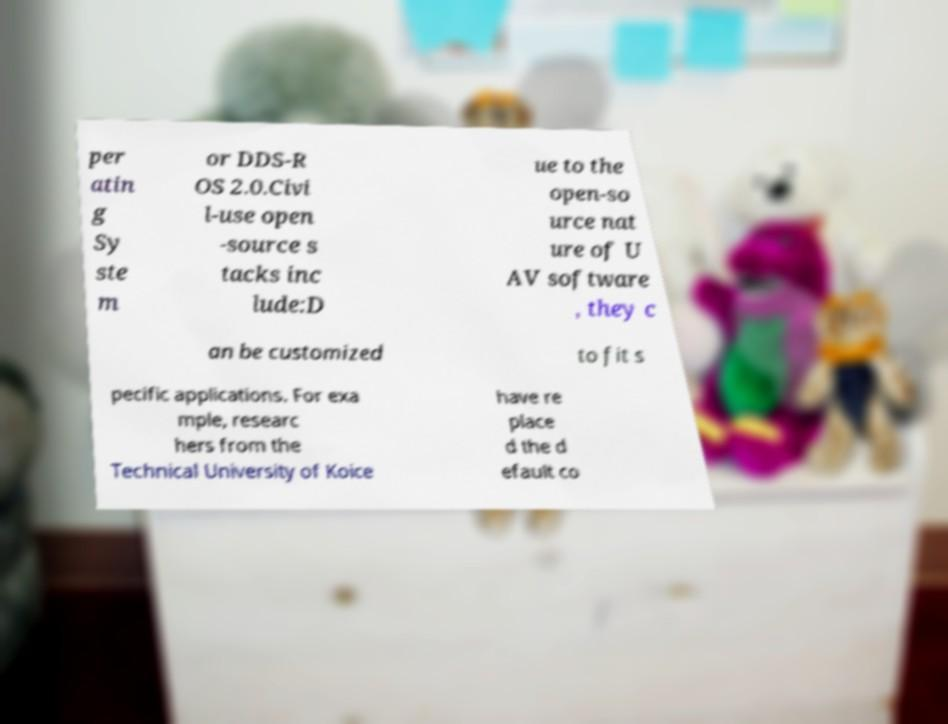There's text embedded in this image that I need extracted. Can you transcribe it verbatim? per atin g Sy ste m or DDS-R OS 2.0.Civi l-use open -source s tacks inc lude:D ue to the open-so urce nat ure of U AV software , they c an be customized to fit s pecific applications. For exa mple, researc hers from the Technical University of Koice have re place d the d efault co 